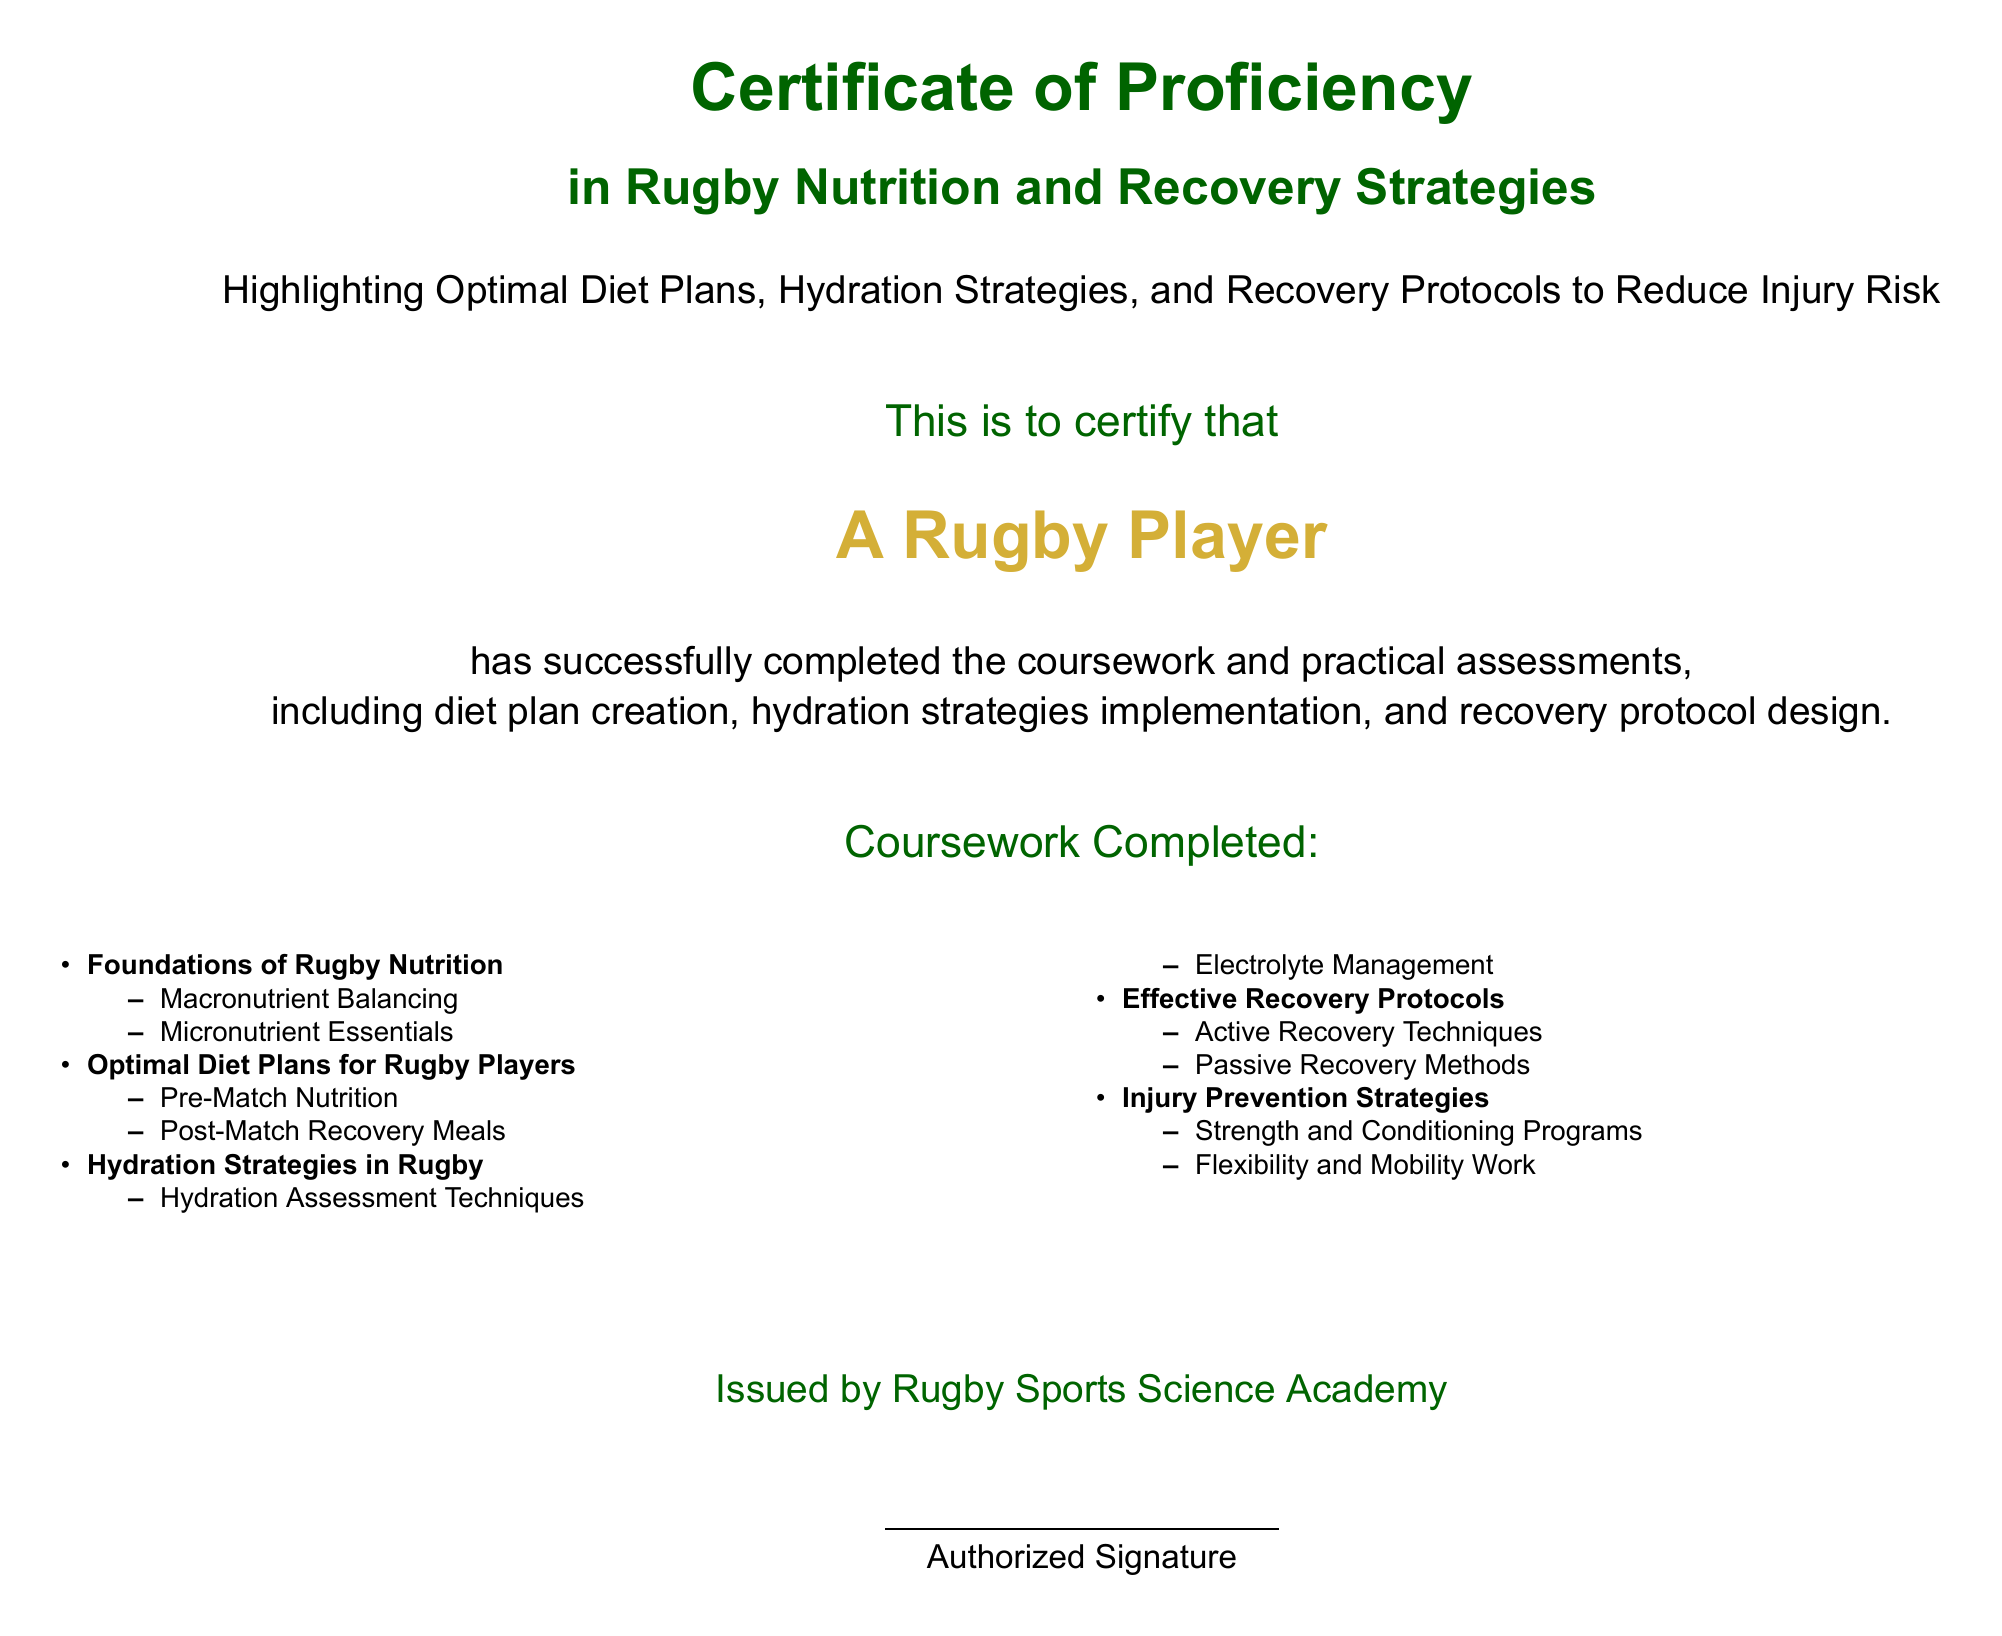What is the title of the certificate? The title is prominently displayed at the top of the document, which is "Certificate of Proficiency in Rugby Nutrition and Recovery Strategies."
Answer: Certificate of Proficiency in Rugby Nutrition and Recovery Strategies Who issued the certificate? The issuing organization is mentioned at the bottom of the document.
Answer: Rugby Sports Science Academy What is one topic covered in the coursework? The coursework section lists several topics, one of which is "Foundations of Rugby Nutrition."
Answer: Foundations of Rugby Nutrition What color is used for the section headings? The section headings are colored with a specific shade of green.
Answer: Rugby green What is one method listed under Effective Recovery Protocols? The document lists various methods under this category, one of which is "Active Recovery Techniques."
Answer: Active Recovery Techniques How many coursework topics are listed? The document lists five distinct topics in the coursework section.
Answer: Five What is the color of the authorized signature line? The color of the line is black, as shown in the signature section.
Answer: Black What are the two components of injury prevention strategies mentioned? The document lists "Strength and Conditioning Programs" and "Flexibility and Mobility Work" as components.
Answer: Strength and Conditioning Programs, Flexibility and Mobility Work 